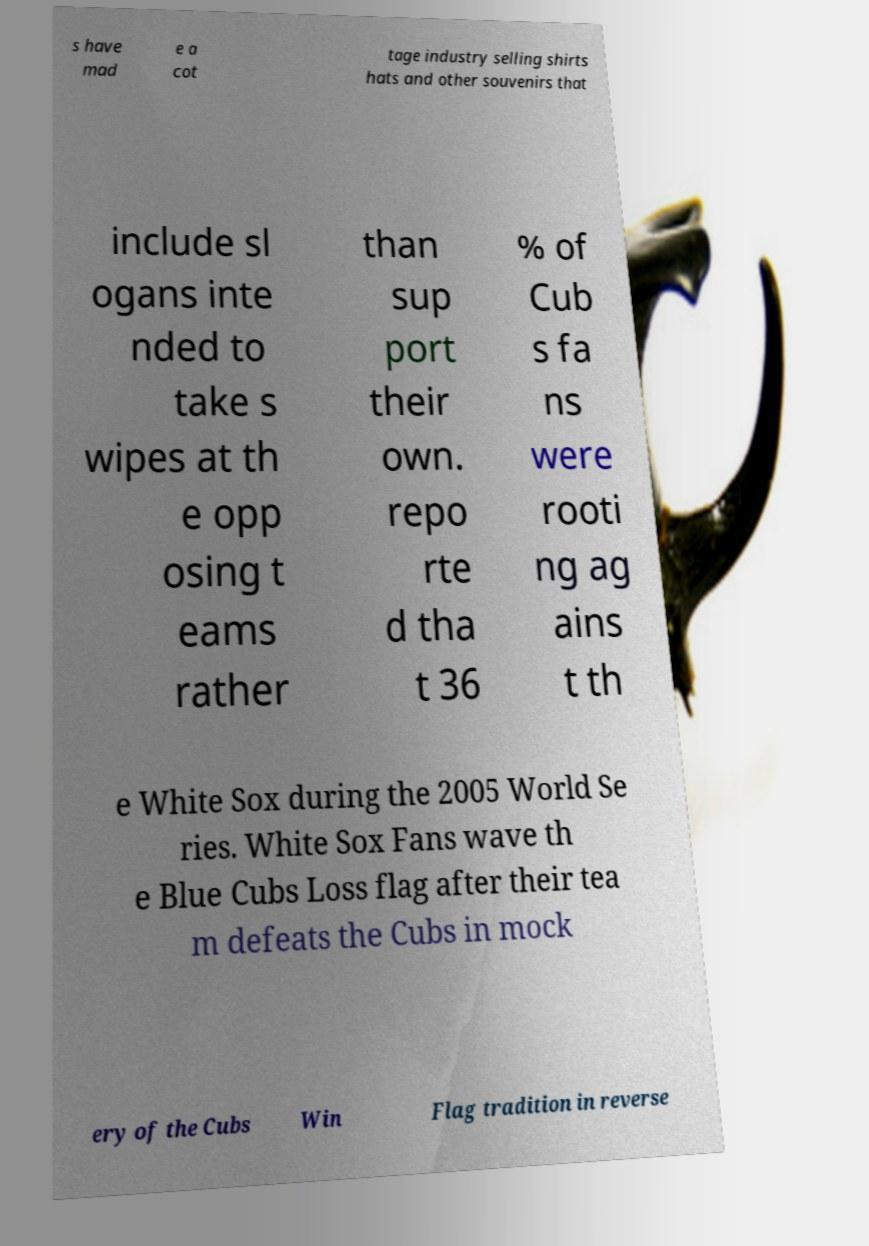I need the written content from this picture converted into text. Can you do that? s have mad e a cot tage industry selling shirts hats and other souvenirs that include sl ogans inte nded to take s wipes at th e opp osing t eams rather than sup port their own. repo rte d tha t 36 % of Cub s fa ns were rooti ng ag ains t th e White Sox during the 2005 World Se ries. White Sox Fans wave th e Blue Cubs Loss flag after their tea m defeats the Cubs in mock ery of the Cubs Win Flag tradition in reverse 